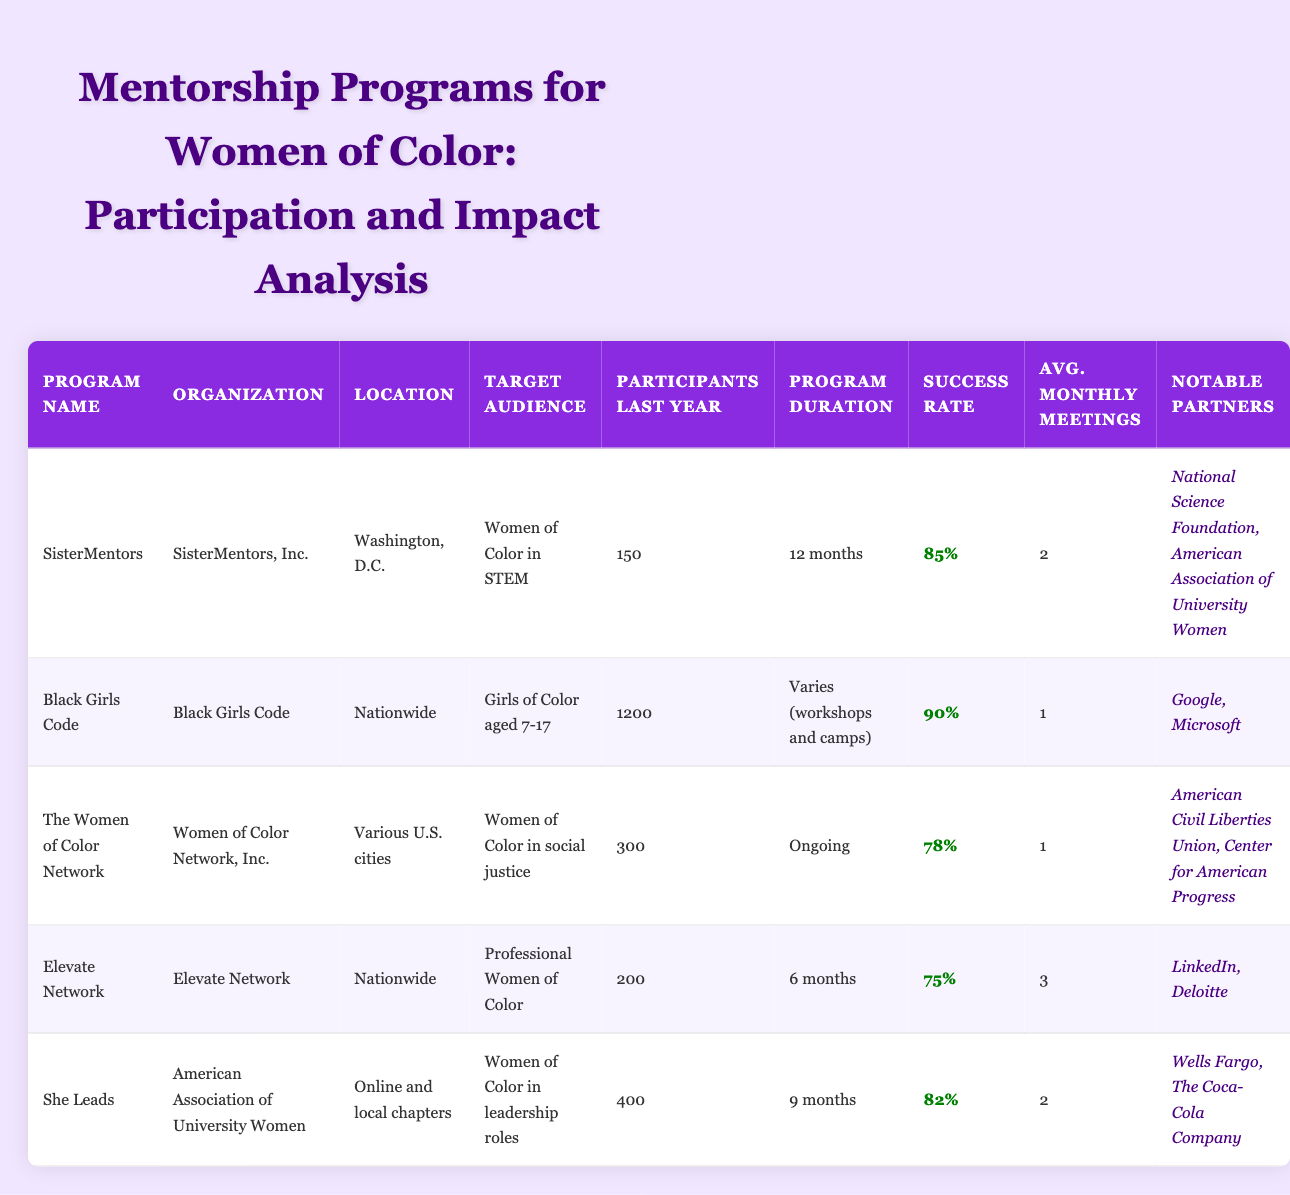What is the target audience for the "She Leads" program? The target audience for the "She Leads" program is specified in the table as women of color in leadership roles. This information can be found directly in the "Target Audience" column corresponding to "She Leads".
Answer: Women of Color in leadership roles Which program has the highest success rate? The success rates for each program are listed in the "Success Rate" column. "Black Girls Code" has a success rate of 90%, which is the highest among the provided programs. Thus, it is concluded by comparing all success rates listed in the table.
Answer: Black Girls Code How many participants did "Elevate Network" have last year? The "Participants Last Year" column shows that "Elevate Network" had 200 participants in the last year. This information can be found directly in the table.
Answer: 200 What is the average number of monthly meetings across all programs? To find the average, sum the "Avg. Monthly Meetings" values: (2 + 1 + 1 + 3 + 2) = 9. Then divide by the number of programs (5) to find the average: 9/5 = 1.8. This calculation is carried out by adding the meetings together and dividing by the number of programs.
Answer: 1.8 Did "SisterMentors" have more participants last year than "The Women of Color Network"? "SisterMentors" had 150 participants last year, while "The Women of Color Network" had 300 participants. Since 150 is less than 300, it confirms that "SisterMentors" had fewer participants. The answer is derived by directly comparing the participant numbers from both entries.
Answer: No How many notable partners does "Black Girls Code" have? The "Notable Partners" column for "Black Girls Code" lists Google and Microsoft, which totals to 2 notable partners. This is simply counted from the current entry's notable partners.
Answer: 2 Which program is aimed at the widest audience based on the number of participants last year? By examining the "Participants Last Year" figures: 150 (SisterMentors), 1200 (Black Girls Code), 300 (The Women of Color Network), 200 (Elevate Network), and 400 (She Leads), we see that "Black Girls Code" had the highest with 1200 participants, thus serving the widest audience. The conclusion is reached by identifying and comparing participant counts from each row.
Answer: Black Girls Code Is "Elevate Network" targeted towards women of color in social justice? The "Target Audience" for "Elevate Network" is listed as professional women of color, while the specific aim for social justice is designated to "The Women of Color Network". Therefore, "Elevate Network" does not specifically target women of color in social justice, based on the details provided in the table.
Answer: No 